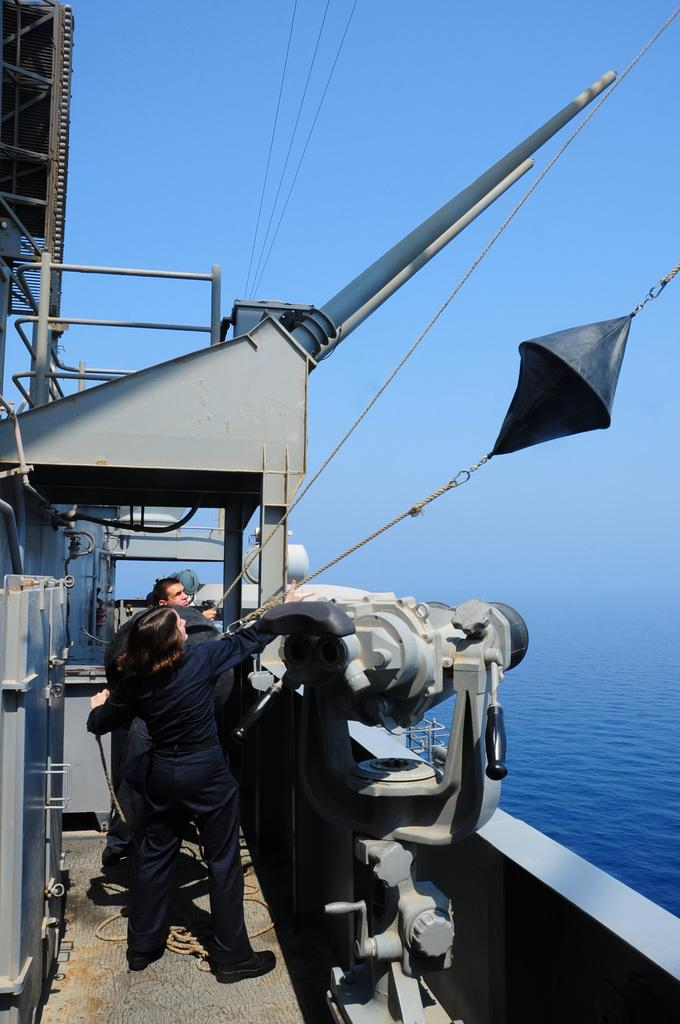What is the main subject of the image? The main subject of the image is a ship. Where is the ship located? The ship is on the water. Are there any people present in the image? Yes, there are people on the ship. What type of tramp can be seen jumping off the ship in the image? There is no tramp present in the image, and no one is jumping off the ship. 